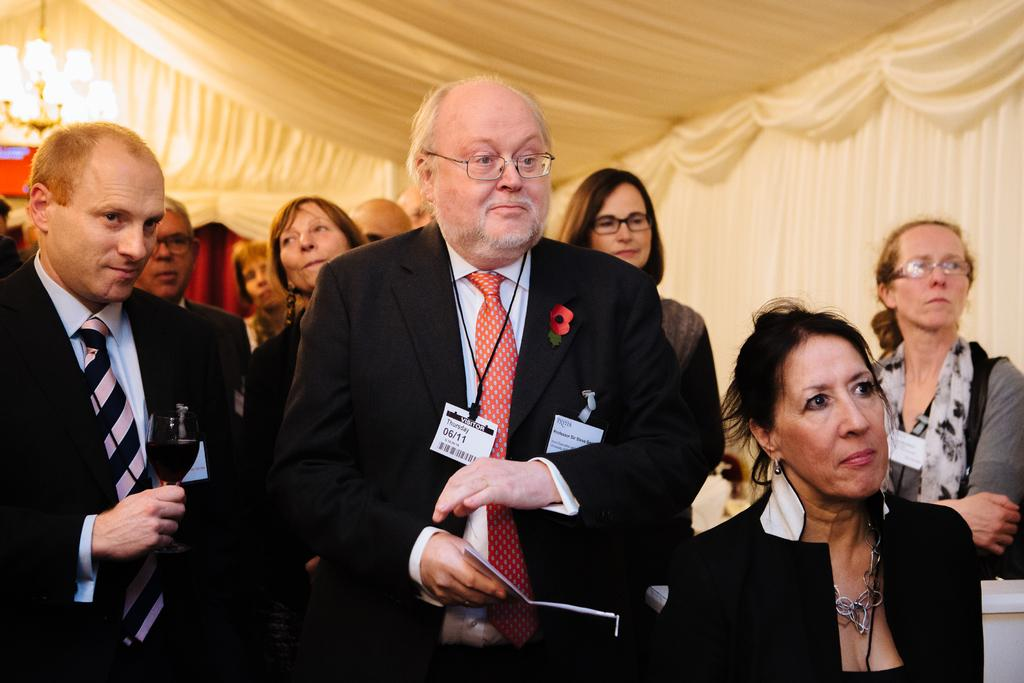What can be seen in the image? There are people standing in the image. Can you describe the man on the left side of the image? The man on the left side of the image is holding a wine glass. What is visible in the background of the image? There is a curtain and a chandelier visible in the background of the image. How does the wind affect the dad's lead in the image? There is no dad or lead present in the image; it only features people standing and a man holding a wine glass. 